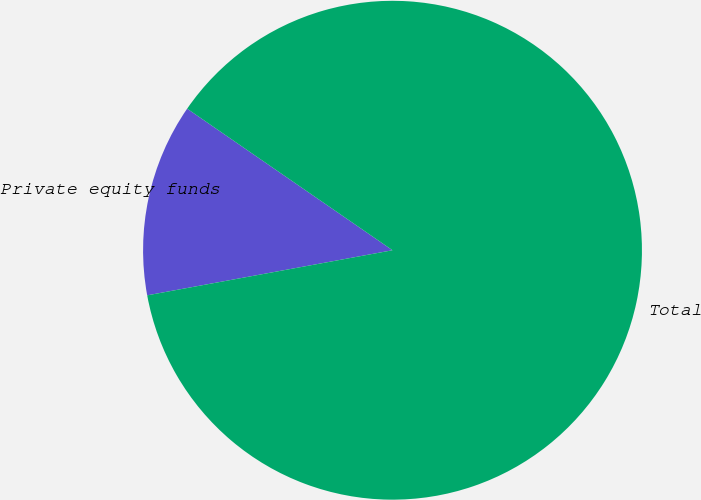Convert chart. <chart><loc_0><loc_0><loc_500><loc_500><pie_chart><fcel>Private equity funds<fcel>Total<nl><fcel>12.5%<fcel>87.5%<nl></chart> 